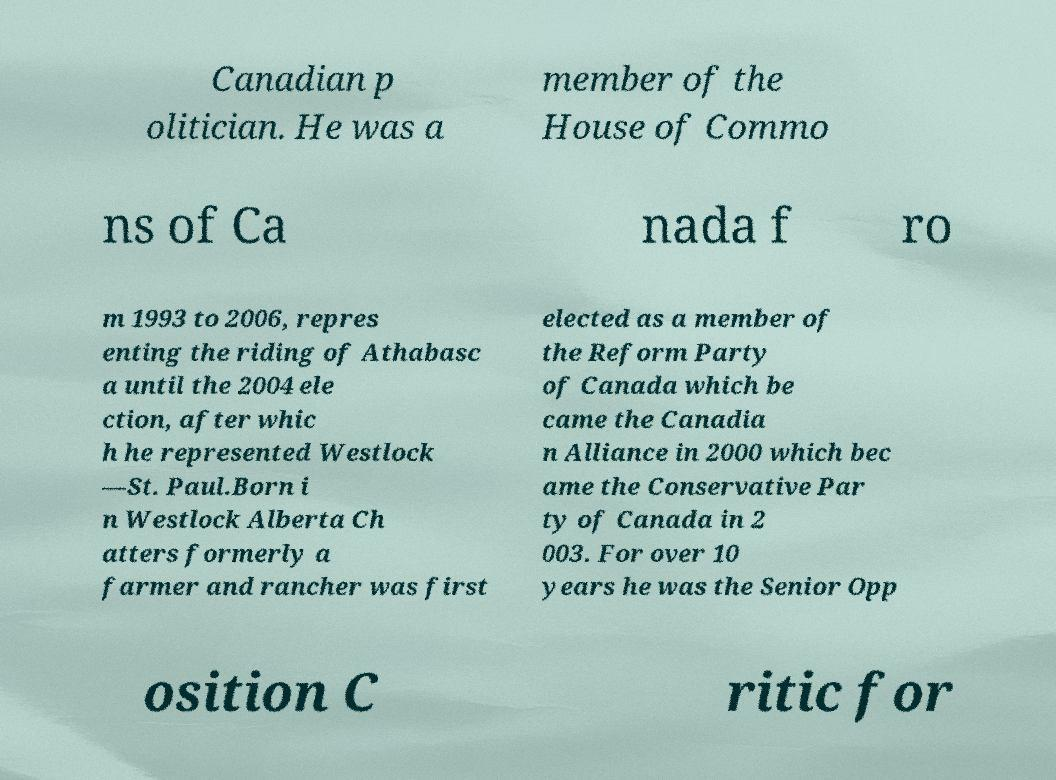There's text embedded in this image that I need extracted. Can you transcribe it verbatim? Canadian p olitician. He was a member of the House of Commo ns of Ca nada f ro m 1993 to 2006, repres enting the riding of Athabasc a until the 2004 ele ction, after whic h he represented Westlock —St. Paul.Born i n Westlock Alberta Ch atters formerly a farmer and rancher was first elected as a member of the Reform Party of Canada which be came the Canadia n Alliance in 2000 which bec ame the Conservative Par ty of Canada in 2 003. For over 10 years he was the Senior Opp osition C ritic for 